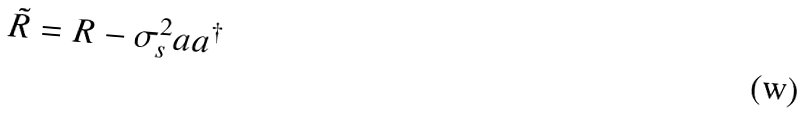Convert formula to latex. <formula><loc_0><loc_0><loc_500><loc_500>\tilde { R } = R - \sigma _ { s } ^ { 2 } a a ^ { \dagger }</formula> 